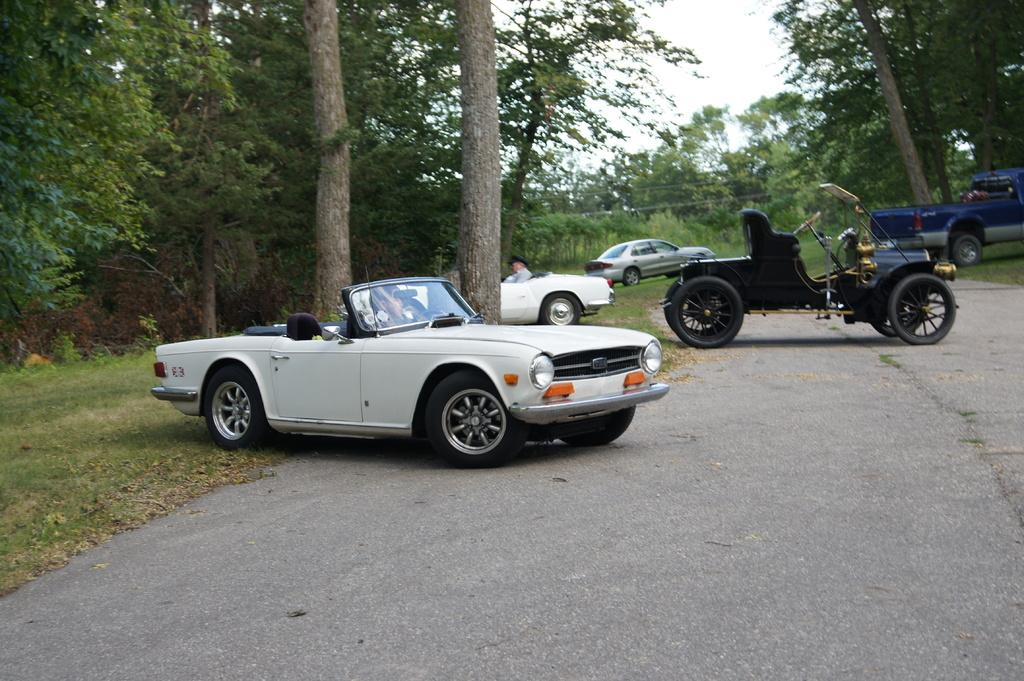What type of vehicles can be seen in the image? There are cars in the image. Is there anyone inside the cars? Yes, a person is sitting in a car. What can be seen in the background of the image? There are trees visible in the image. What type of club is the person holding in the image? There is no club present in the image; the person is sitting in a car. When is the recess taking place in the image? There is no recess mentioned or depicted in the image; it features cars and a person sitting in one of them. 